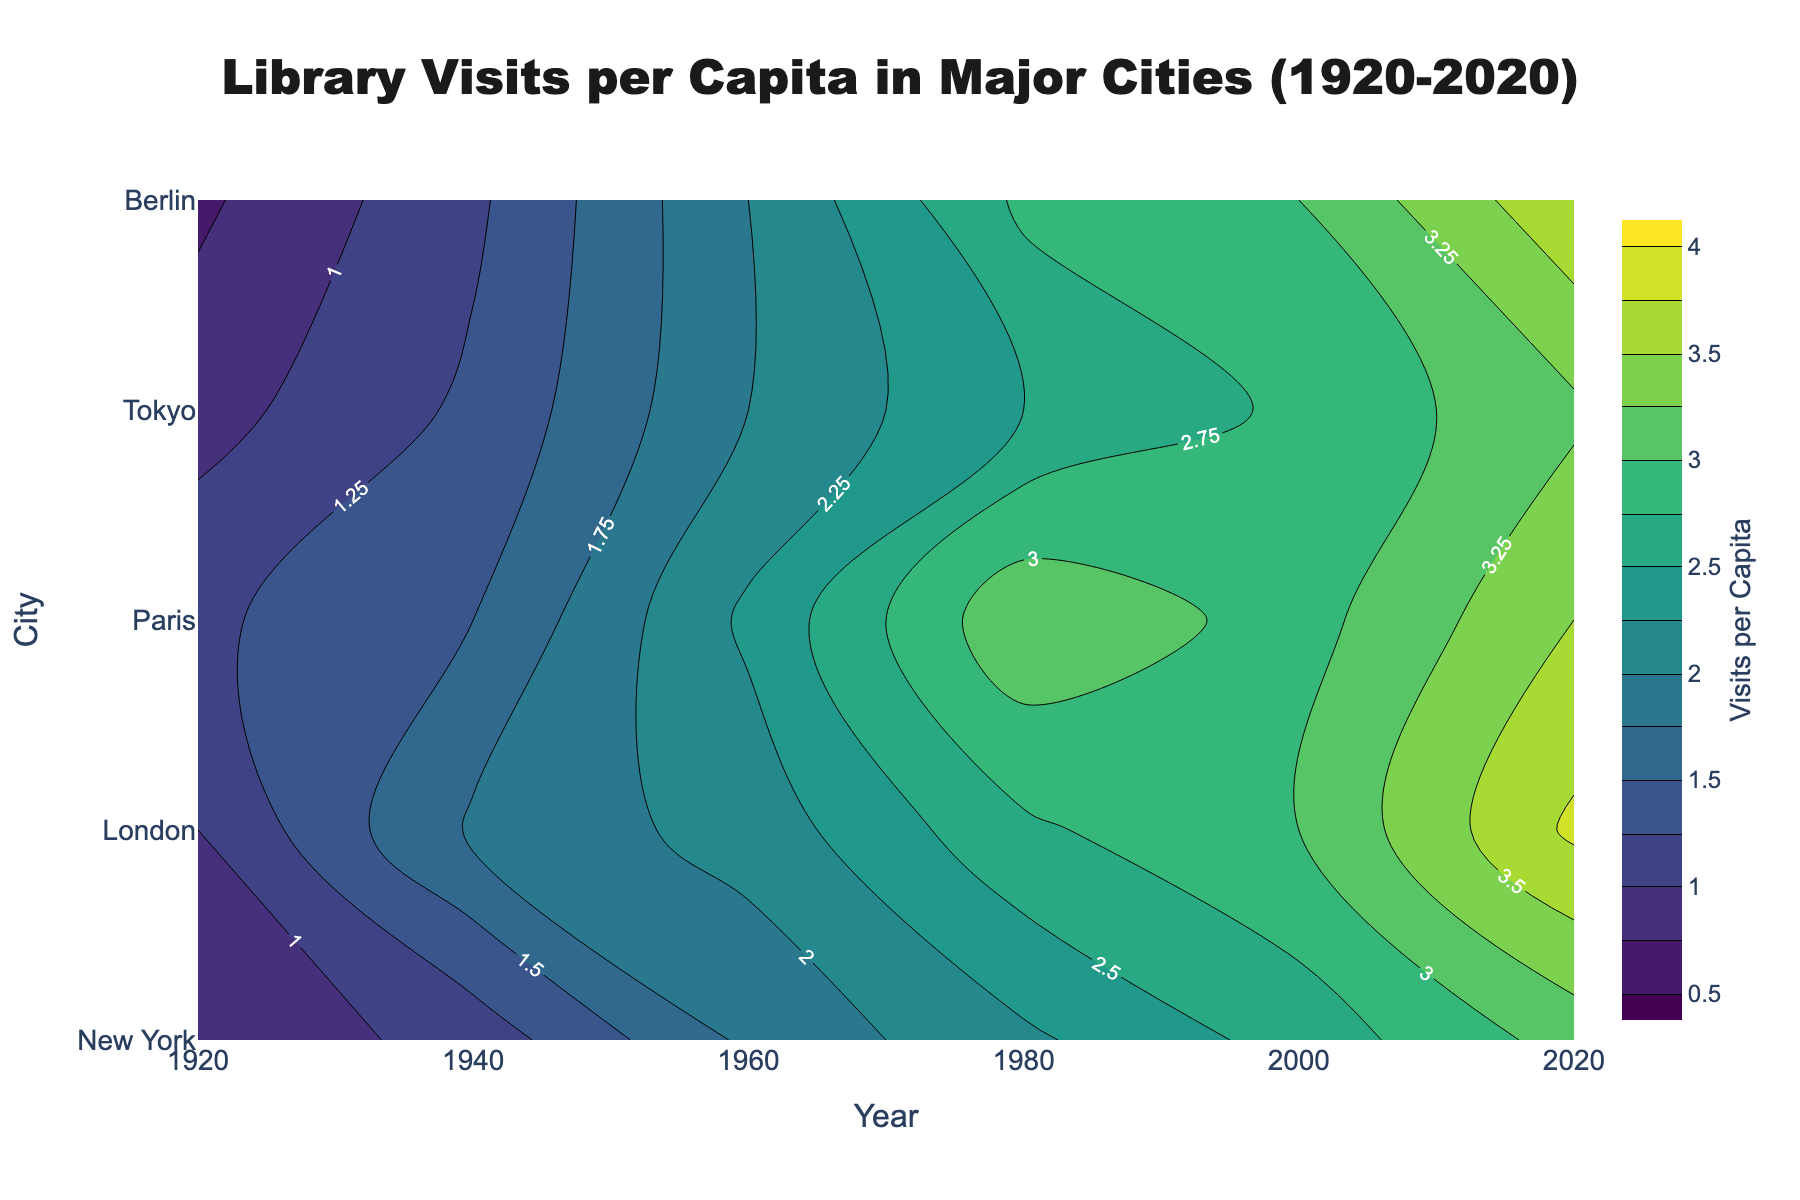What is the title of the figure? The title is located at the top of the figure and is usually in a larger and bold font.
Answer: Library Visits per Capita in Major Cities (1920-2020) Which city had the highest library visits per capita in 2020? In 2020, contour lines at the upper part of the plot need to be examined to see which city reaches the highest value.
Answer: London How did library visits per capita in Tokyo change from 1920 to 2020? Starting at 0.7 in 1920, trace the contour lines for Tokyo along the x-axis until reaching 2020 at 3.7.
Answer: Increased What year saw the highest jump in library visits per capita for New York? By looking at New York's contour lines, the steepest incline will indicate the largest jump, noticeable between the closest lines.
Answer: 1940-1960 Compare library visits per capita between Berlin and Paris in 1960. Locate 1960 on the x-axis and compare the positions of Berlin and Paris on the y-axis within the same column.
Answer: Paris is higher What is the range of library visits per capita values shown in the figure? The contour's color bar indicates the range, starting from the first contour label to the last.
Answer: 0.5 to 4.0 Which city shows the most consistent growth in library visits per capita over time? Consistent growth is indicated by evenly spaced contour lines from one year to the next.
Answer: London How many cities are represented in the plot? Count the distinct labels on the y-axis which represents different cities.
Answer: 5 In which year did all cities have at least 2 visits per capita? Find the first appearance of the contour line for the value 2 that crosses all cities by checking per year.
Answer: 1960 